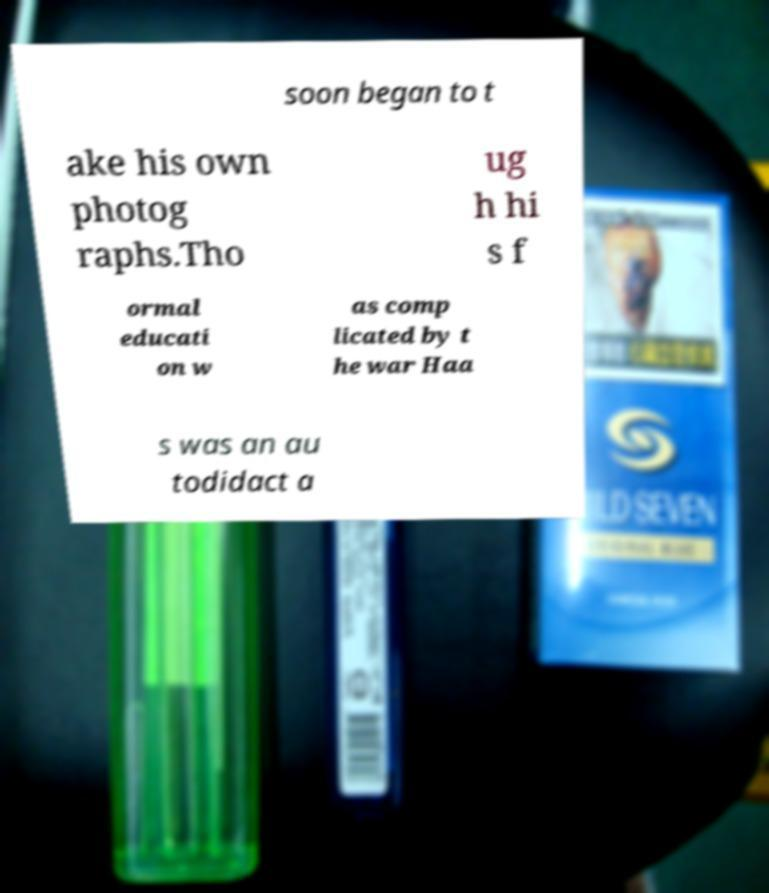There's text embedded in this image that I need extracted. Can you transcribe it verbatim? soon began to t ake his own photog raphs.Tho ug h hi s f ormal educati on w as comp licated by t he war Haa s was an au todidact a 